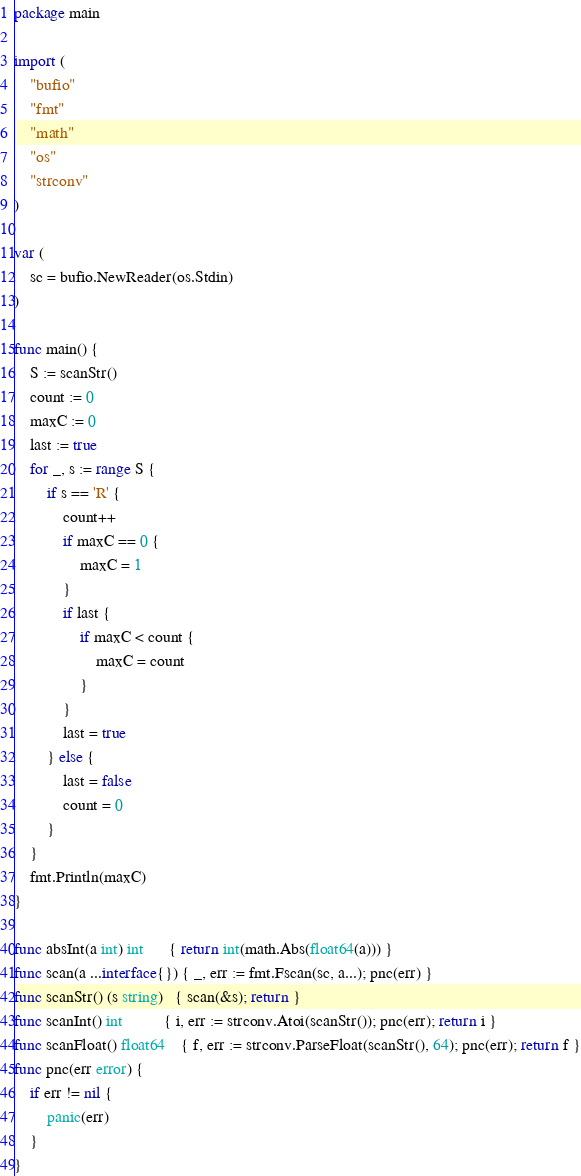Convert code to text. <code><loc_0><loc_0><loc_500><loc_500><_Go_>package main

import (
	"bufio"
	"fmt"
	"math"
	"os"
	"strconv"
)

var (
	sc = bufio.NewReader(os.Stdin)
)

func main() {
	S := scanStr()
	count := 0
	maxC := 0
	last := true
	for _, s := range S {
		if s == 'R' {
			count++
			if maxC == 0 {
				maxC = 1
			}
			if last {
				if maxC < count {
					maxC = count
				}
			}
			last = true
		} else {
			last = false
			count = 0
		}
	}
	fmt.Println(maxC)
}

func absInt(a int) int      { return int(math.Abs(float64(a))) }
func scan(a ...interface{}) { _, err := fmt.Fscan(sc, a...); pnc(err) }
func scanStr() (s string)   { scan(&s); return }
func scanInt() int          { i, err := strconv.Atoi(scanStr()); pnc(err); return i }
func scanFloat() float64    { f, err := strconv.ParseFloat(scanStr(), 64); pnc(err); return f }
func pnc(err error) {
	if err != nil {
		panic(err)
	}
}
</code> 